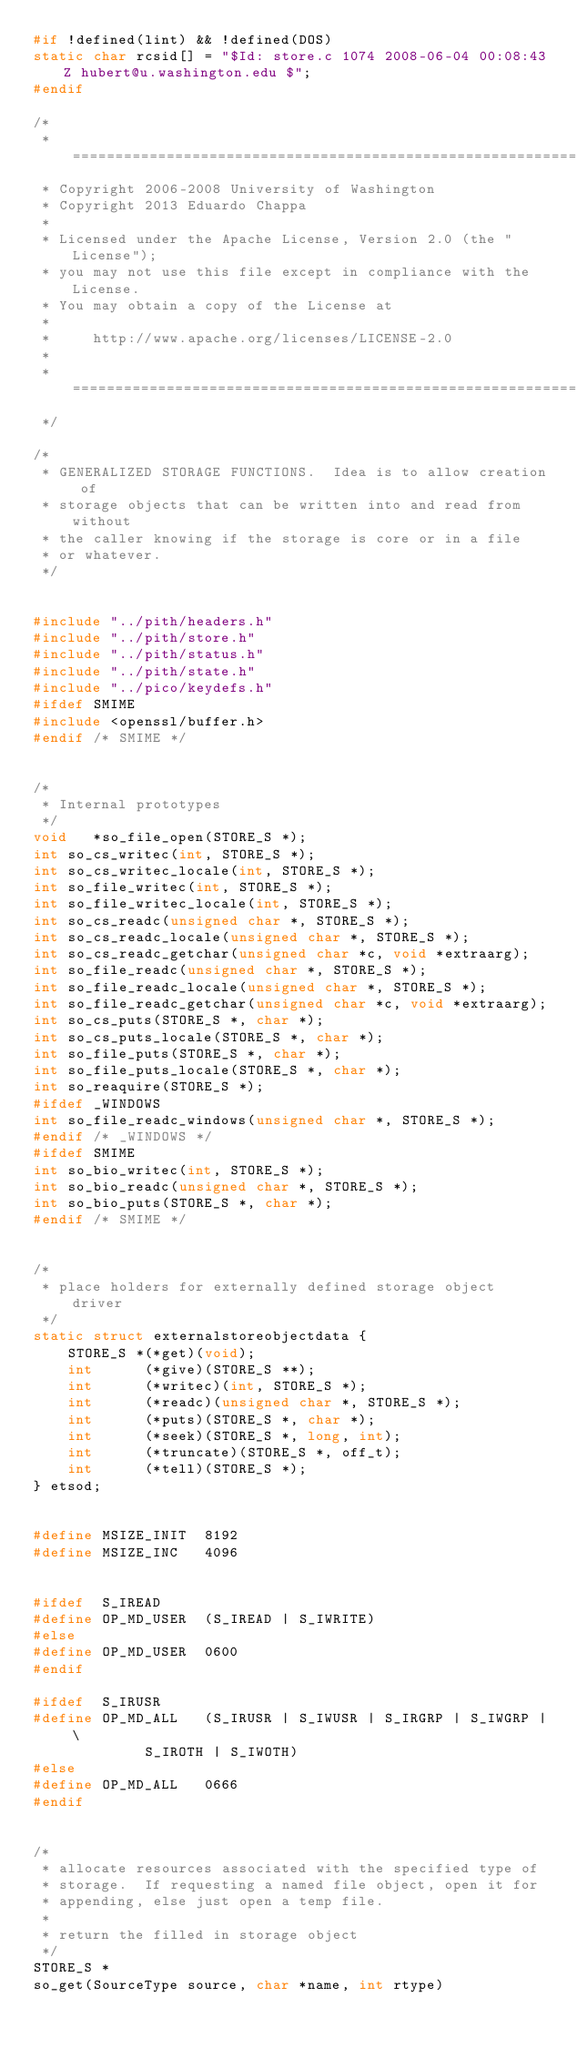Convert code to text. <code><loc_0><loc_0><loc_500><loc_500><_C_>#if !defined(lint) && !defined(DOS)
static char rcsid[] = "$Id: store.c 1074 2008-06-04 00:08:43Z hubert@u.washington.edu $";
#endif

/*
 * ========================================================================
 * Copyright 2006-2008 University of Washington
 * Copyright 2013 Eduardo Chappa
 *
 * Licensed under the Apache License, Version 2.0 (the "License");
 * you may not use this file except in compliance with the License.
 * You may obtain a copy of the License at
 *
 *     http://www.apache.org/licenses/LICENSE-2.0
 *
 * ========================================================================
 */

/*
 * GENERALIZED STORAGE FUNCTIONS.  Idea is to allow creation of
 * storage objects that can be written into and read from without
 * the caller knowing if the storage is core or in a file
 * or whatever.
 */


#include "../pith/headers.h"
#include "../pith/store.h"
#include "../pith/status.h"
#include "../pith/state.h"
#include "../pico/keydefs.h"
#ifdef SMIME
#include <openssl/buffer.h>
#endif /* SMIME */


/*
 * Internal prototypes
 */
void   *so_file_open(STORE_S *);
int	so_cs_writec(int, STORE_S *);
int	so_cs_writec_locale(int, STORE_S *);
int	so_file_writec(int, STORE_S *);
int	so_file_writec_locale(int, STORE_S *);
int	so_cs_readc(unsigned char *, STORE_S *);
int	so_cs_readc_locale(unsigned char *, STORE_S *);
int	so_cs_readc_getchar(unsigned char *c, void *extraarg);
int	so_file_readc(unsigned char *, STORE_S *);
int	so_file_readc_locale(unsigned char *, STORE_S *);
int	so_file_readc_getchar(unsigned char *c, void *extraarg);
int	so_cs_puts(STORE_S *, char *);
int	so_cs_puts_locale(STORE_S *, char *);
int	so_file_puts(STORE_S *, char *);
int	so_file_puts_locale(STORE_S *, char *);
int	so_reaquire(STORE_S *);
#ifdef _WINDOWS
int	so_file_readc_windows(unsigned char *, STORE_S *);
#endif /* _WINDOWS */
#ifdef SMIME
int	so_bio_writec(int, STORE_S *);
int	so_bio_readc(unsigned char *, STORE_S *);
int	so_bio_puts(STORE_S *, char *);
#endif /* SMIME */


/*
 * place holders for externally defined storage object driver
 */
static struct externalstoreobjectdata {
    STORE_S *(*get)(void);
    int      (*give)(STORE_S **);
    int      (*writec)(int, STORE_S *);
    int      (*readc)(unsigned char *, STORE_S *);
    int      (*puts)(STORE_S *, char *);
    int      (*seek)(STORE_S *, long, int);
    int      (*truncate)(STORE_S *, off_t);
    int      (*tell)(STORE_S *);
} etsod;


#define	MSIZE_INIT	8192
#define	MSIZE_INC	4096


#ifdef	S_IREAD
#define	OP_MD_USER	(S_IREAD | S_IWRITE)
#else
#define	OP_MD_USER	0600
#endif

#ifdef	S_IRUSR
#define	OP_MD_ALL	(S_IRUSR | S_IWUSR | S_IRGRP | S_IWGRP | \
			 S_IROTH | S_IWOTH)
#else
#define	OP_MD_ALL	0666
#endif


/*
 * allocate resources associated with the specified type of
 * storage.  If requesting a named file object, open it for
 * appending, else just open a temp file.
 *
 * return the filled in storage object
 */
STORE_S *
so_get(SourceType source, char *name, int rtype)</code> 